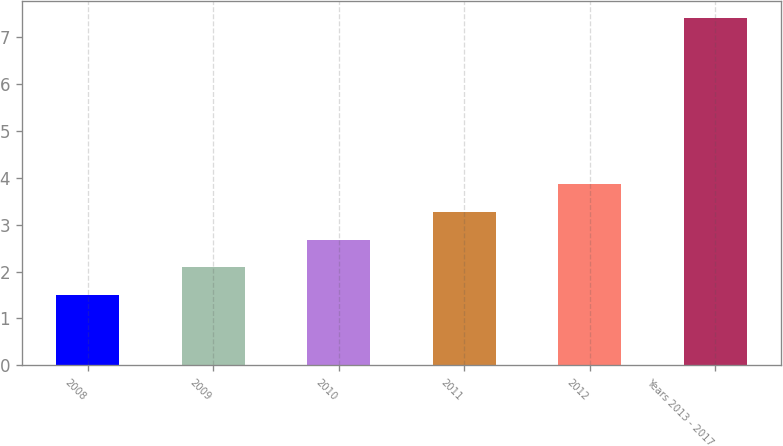Convert chart to OTSL. <chart><loc_0><loc_0><loc_500><loc_500><bar_chart><fcel>2008<fcel>2009<fcel>2010<fcel>2011<fcel>2012<fcel>Years 2013 - 2017<nl><fcel>1.5<fcel>2.09<fcel>2.68<fcel>3.27<fcel>3.86<fcel>7.4<nl></chart> 